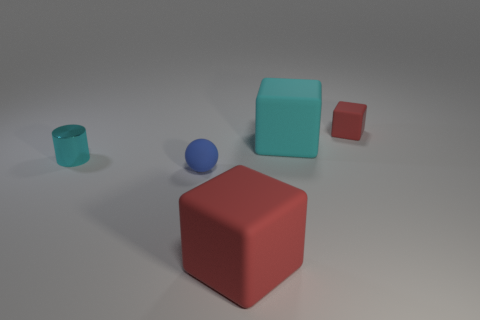There is a cyan thing that is on the right side of the large red rubber object that is in front of the cyan shiny thing; what is its size?
Keep it short and to the point. Large. Are the large block behind the small ball and the large red thing made of the same material?
Ensure brevity in your answer.  Yes. The large matte object behind the tiny metal thing has what shape?
Offer a terse response. Cube. How many other blue spheres have the same size as the ball?
Keep it short and to the point. 0. The cyan cube has what size?
Your response must be concise. Large. There is a large cyan cube; what number of small red rubber things are behind it?
Give a very brief answer. 1. What is the shape of the other red object that is the same material as the big red thing?
Make the answer very short. Cube. Is the number of red cubes that are on the left side of the blue object less than the number of red things in front of the big cyan cube?
Give a very brief answer. Yes. Are there more tiny brown metal blocks than small objects?
Offer a very short reply. No. What is the material of the small cylinder?
Ensure brevity in your answer.  Metal. 